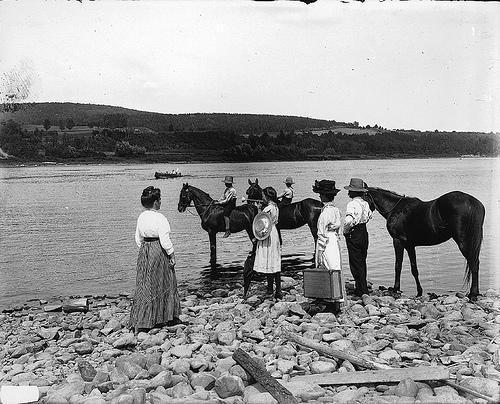How many horses are pictured?
Give a very brief answer. 3. How many horses are in the picture?
Give a very brief answer. 2. How many people are visible?
Give a very brief answer. 3. How many train cars are orange?
Give a very brief answer. 0. 